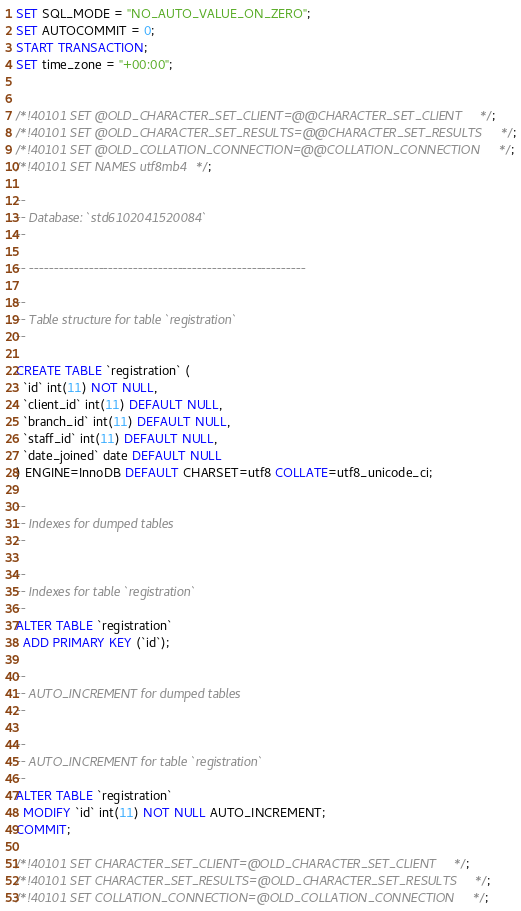Convert code to text. <code><loc_0><loc_0><loc_500><loc_500><_SQL_>
SET SQL_MODE = "NO_AUTO_VALUE_ON_ZERO";
SET AUTOCOMMIT = 0;
START TRANSACTION;
SET time_zone = "+00:00";


/*!40101 SET @OLD_CHARACTER_SET_CLIENT=@@CHARACTER_SET_CLIENT */;
/*!40101 SET @OLD_CHARACTER_SET_RESULTS=@@CHARACTER_SET_RESULTS */;
/*!40101 SET @OLD_COLLATION_CONNECTION=@@COLLATION_CONNECTION */;
/*!40101 SET NAMES utf8mb4 */;

--
-- Database: `std6102041520084`
--

-- --------------------------------------------------------

--
-- Table structure for table `registration`
--

CREATE TABLE `registration` (
  `id` int(11) NOT NULL,
  `client_id` int(11) DEFAULT NULL,
  `branch_id` int(11) DEFAULT NULL,
  `staff_id` int(11) DEFAULT NULL,
  `date_joined` date DEFAULT NULL
) ENGINE=InnoDB DEFAULT CHARSET=utf8 COLLATE=utf8_unicode_ci;

--
-- Indexes for dumped tables
--

--
-- Indexes for table `registration`
--
ALTER TABLE `registration`
  ADD PRIMARY KEY (`id`);

--
-- AUTO_INCREMENT for dumped tables
--

--
-- AUTO_INCREMENT for table `registration`
--
ALTER TABLE `registration`
  MODIFY `id` int(11) NOT NULL AUTO_INCREMENT;
COMMIT;

/*!40101 SET CHARACTER_SET_CLIENT=@OLD_CHARACTER_SET_CLIENT */;
/*!40101 SET CHARACTER_SET_RESULTS=@OLD_CHARACTER_SET_RESULTS */;
/*!40101 SET COLLATION_CONNECTION=@OLD_COLLATION_CONNECTION */;
</code> 